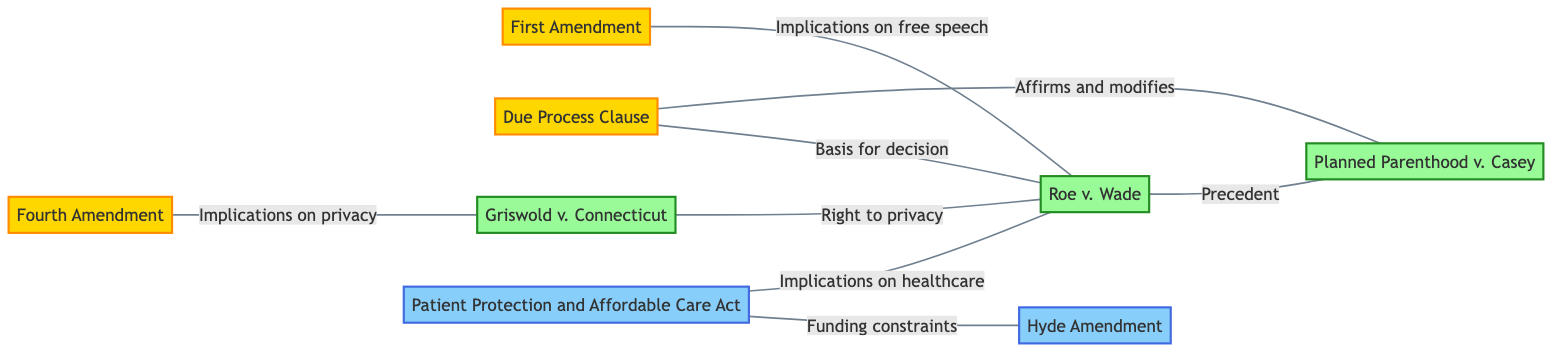What is the total number of nodes in the diagram? Counting the nodes listed in the data section, we find 8 entities: First Amendment, Fourth Amendment, Due Process Clause, Roe v. Wade, Planned Parenthood v. Casey, Griswold v. Connecticut, Patient Protection and Affordable Care Act, and Hyde Amendment.
Answer: 8 Which court case is connected to the Due Process Clause? Looking at the edges from the Due Process Clause, we see that it connects to Roe v. Wade (labeled "Basis for decision") and Planned Parenthood v. Casey (labeled "Affirms and modifies"). Therefore, Roe v. Wade is the primary connection.
Answer: Roe v. Wade What relationship connects the Fourth Amendment to the Griswold v. Connecticut case? The edge between the Fourth Amendment and Griswold v. Connecticut indicates "Implications on privacy." This shows that the Fourth Amendment is related to privacy issues addressed in the Griswold case.
Answer: Implications on privacy Which two cases are a direct precedent for Planned Parenthood v. Casey? Planned Parenthood v. Casey is directly connected to both Roe v. Wade (labeled "Precedent") and Due Process Clause (labeled "Affirms and modifies"). This means both Roe v. Wade and the Due Process Clause serve as precedent.
Answer: Roe v. Wade and Due Process Clause How many amendments are involved in this diagram? From the nodes listed, we find three amendments: First Amendment, Fourth Amendment, and Due Process Clause.
Answer: 3 Which law is linked to both the Hyde Amendment and the Roe v. Wade case? The Patient Protection and Affordable Care Act is connected to both the Hyde Amendment (labeled "Funding constraints") and Roe v. Wade (labeled "Implications on healthcare"). This indicates its relevance to both legal areas.
Answer: Patient Protection and Affordable Care Act What is the relationship between Griswold v. Connecticut and Roe v. Wade? The graph shows a connection from Griswold v. Connecticut to Roe v. Wade, labeled "Right to privacy." This indicates that Griswold v. Connecticut is a foundational case supporting the right to privacy discussed in Roe v. Wade.
Answer: Right to privacy How many edges are in the diagram? By counting the edges listed in the data, there are 8 connections described, linking various nodes in the diagram.
Answer: 8 Which amendment is related to first amendment allegations in Roe v. Wade? The edge connecting the First Amendment and Roe v. Wade is labeled "Implications on free speech," highlighting free speech considerations in the court ruling.
Answer: Implications on free speech 